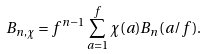Convert formula to latex. <formula><loc_0><loc_0><loc_500><loc_500>B _ { n , \chi } = f ^ { n - 1 } \sum _ { a = 1 } ^ { f } \chi ( a ) B _ { n } ( a / f ) .</formula> 